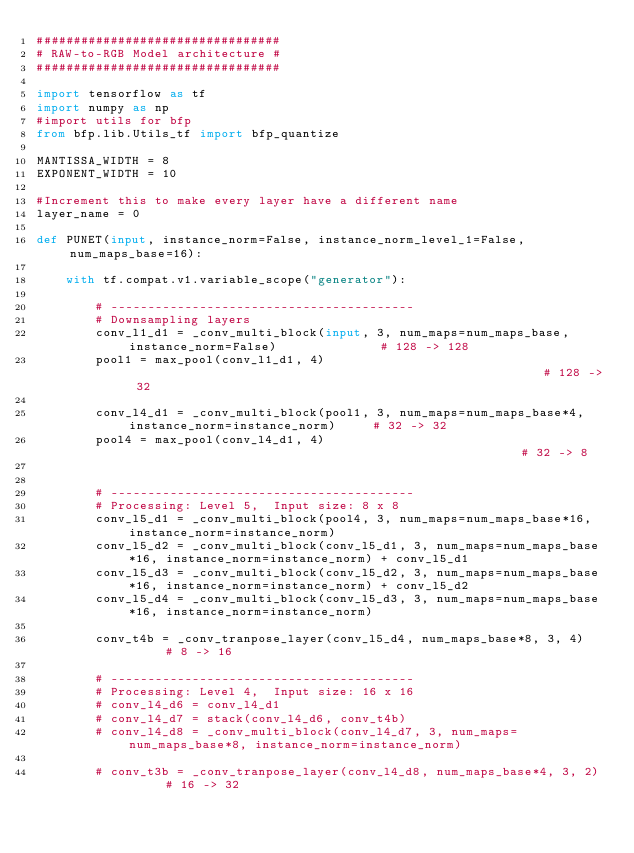Convert code to text. <code><loc_0><loc_0><loc_500><loc_500><_Python_>#################################
# RAW-to-RGB Model architecture #
#################################

import tensorflow as tf
import numpy as np
#import utils for bfp
from bfp.lib.Utils_tf import bfp_quantize

MANTISSA_WIDTH = 8
EXPONENT_WIDTH = 10

#Increment this to make every layer have a different name
layer_name = 0

def PUNET(input, instance_norm=False, instance_norm_level_1=False, num_maps_base=16):

    with tf.compat.v1.variable_scope("generator"):

        # -----------------------------------------
        # Downsampling layers
        conv_l1_d1 = _conv_multi_block(input, 3, num_maps=num_maps_base, instance_norm=False)              # 128 -> 128
        pool1 = max_pool(conv_l1_d1, 4)                                                         # 128 -> 32

        conv_l4_d1 = _conv_multi_block(pool1, 3, num_maps=num_maps_base*4, instance_norm=instance_norm)     # 32 -> 32
        pool4 = max_pool(conv_l4_d1, 4)                                                      # 32 -> 8


        # -----------------------------------------
        # Processing: Level 5,  Input size: 8 x 8
        conv_l5_d1 = _conv_multi_block(pool4, 3, num_maps=num_maps_base*16, instance_norm=instance_norm)
        conv_l5_d2 = _conv_multi_block(conv_l5_d1, 3, num_maps=num_maps_base*16, instance_norm=instance_norm) + conv_l5_d1
        conv_l5_d3 = _conv_multi_block(conv_l5_d2, 3, num_maps=num_maps_base*16, instance_norm=instance_norm) + conv_l5_d2
        conv_l5_d4 = _conv_multi_block(conv_l5_d3, 3, num_maps=num_maps_base*16, instance_norm=instance_norm)

        conv_t4b = _conv_tranpose_layer(conv_l5_d4, num_maps_base*8, 3, 4)      # 8 -> 16

        # -----------------------------------------
        # Processing: Level 4,  Input size: 16 x 16
        # conv_l4_d6 = conv_l4_d1
        # conv_l4_d7 = stack(conv_l4_d6, conv_t4b)
        # conv_l4_d8 = _conv_multi_block(conv_l4_d7, 3, num_maps=num_maps_base*8, instance_norm=instance_norm)

        # conv_t3b = _conv_tranpose_layer(conv_l4_d8, num_maps_base*4, 3, 2)      # 16 -> 32
</code> 